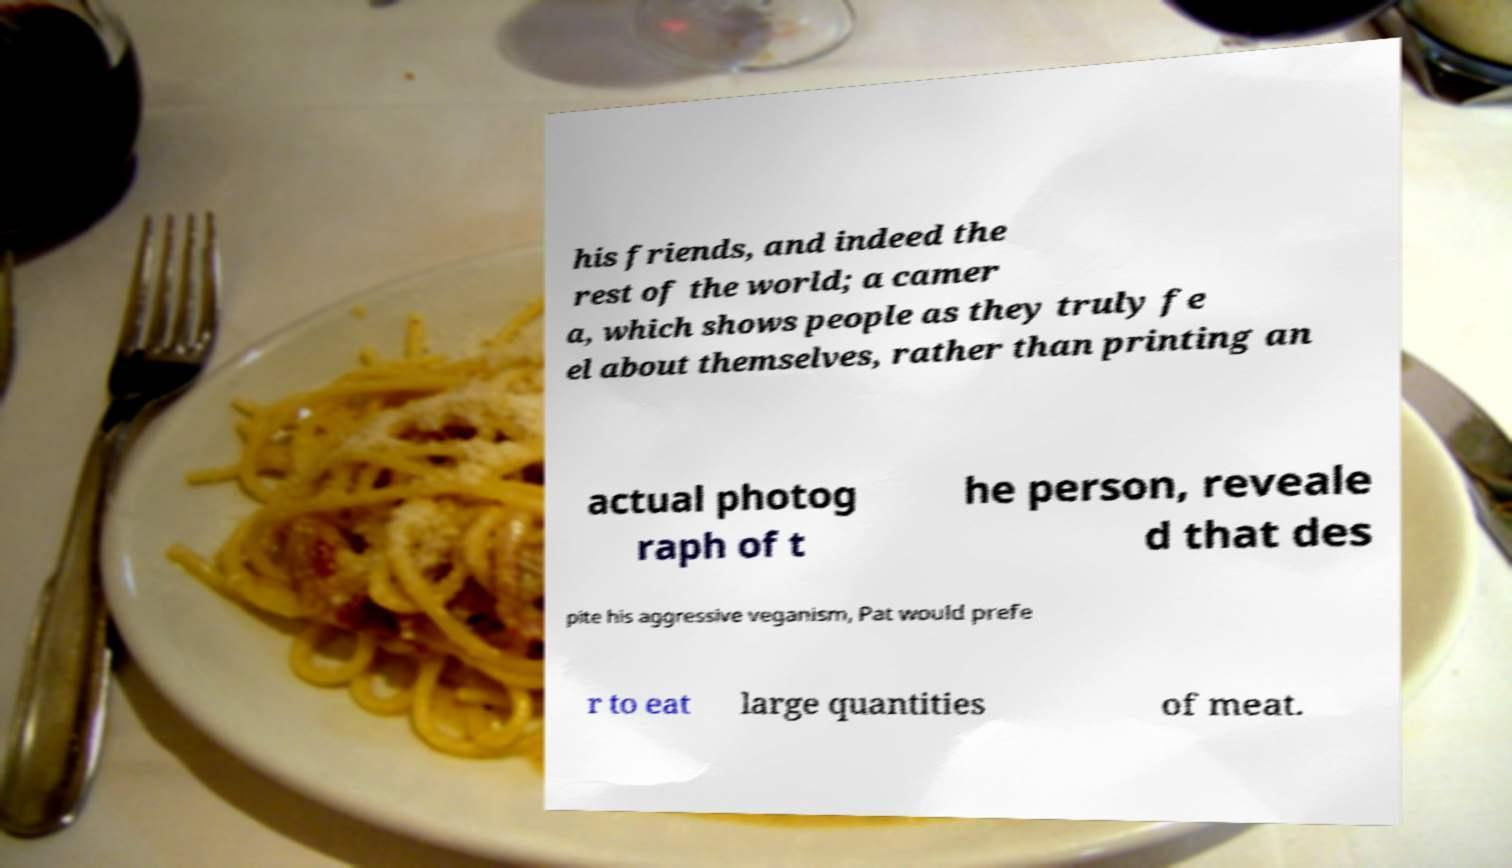For documentation purposes, I need the text within this image transcribed. Could you provide that? his friends, and indeed the rest of the world; a camer a, which shows people as they truly fe el about themselves, rather than printing an actual photog raph of t he person, reveale d that des pite his aggressive veganism, Pat would prefe r to eat large quantities of meat. 